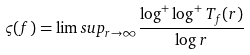Convert formula to latex. <formula><loc_0><loc_0><loc_500><loc_500>\varsigma ( f ) = \lim s u p _ { r \to \infty } \frac { \log ^ { + } \log ^ { + } T _ { f } ( r ) } { \log r }</formula> 